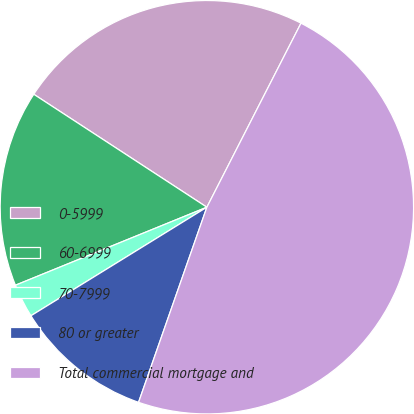<chart> <loc_0><loc_0><loc_500><loc_500><pie_chart><fcel>0-5999<fcel>60-6999<fcel>70-7999<fcel>80 or greater<fcel>Total commercial mortgage and<nl><fcel>23.32%<fcel>15.36%<fcel>2.64%<fcel>10.84%<fcel>47.83%<nl></chart> 